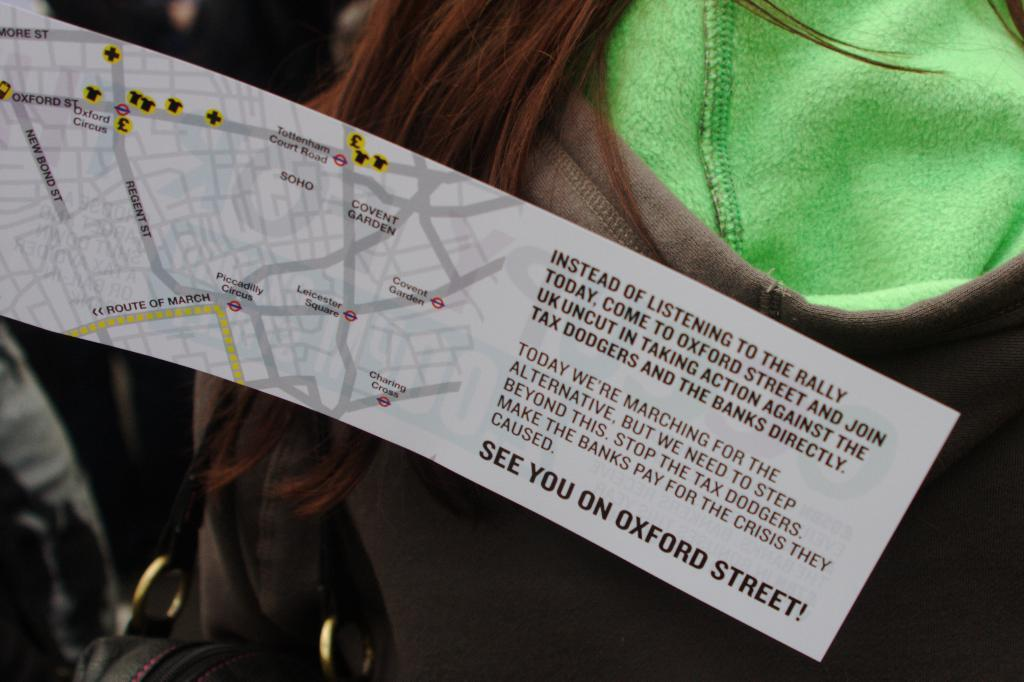What is depicted on the paper in the image? The paper has a map on it. Are there any words or letters on the paper? Yes, there is text on the paper. Can you describe the person in the image? The person is wearing a jacket. What might the person be using the paper for? The person might be using the paper with the map and text for navigation or reference. How many people are in the crowd in the image? There is no crowd present in the image; it only features a person with a paper. 